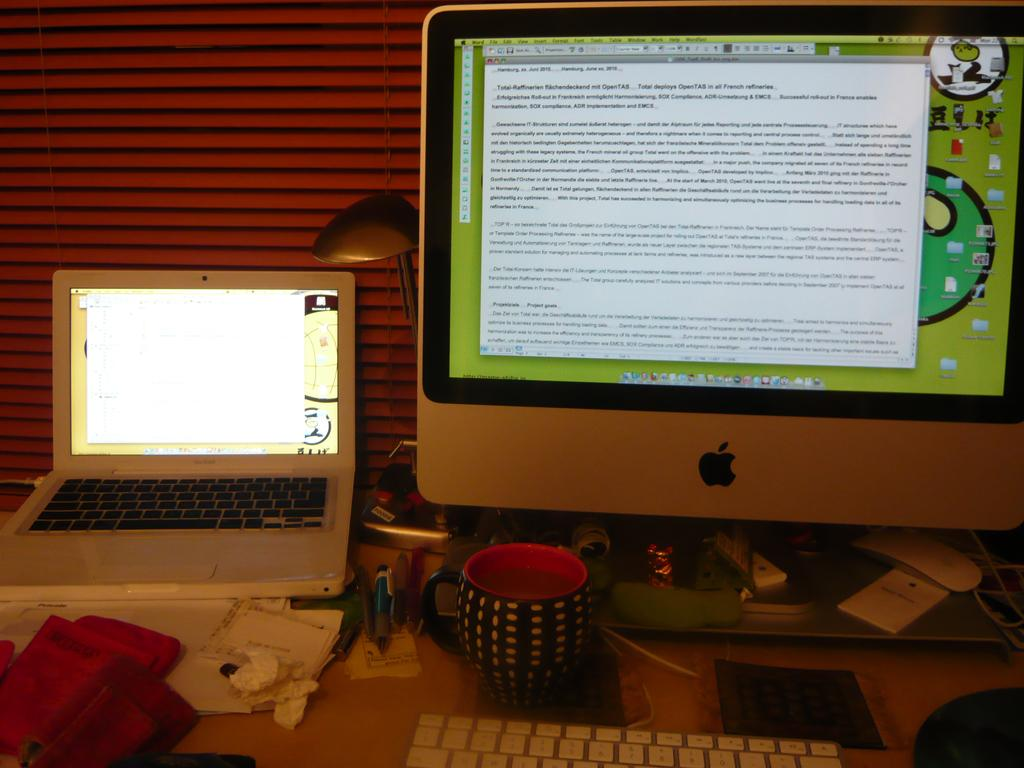What electronic device is on the table in the image? There is a laptop on the table in the image. What other computer components are on the table? There is a CPU and a monitor on the table. What input device is on the table? There is a keyboard on the table. What type of material is on the table? There is a cloth and tissue paper on the table. What stationery items are on the table? There are pens on the table. What can be seen in the background of the image? There is a wall visible in the background. What type of crown is placed on the laptop in the image? There is no crown present in the image; it features a laptop, computer components, and other accessories on a table. 